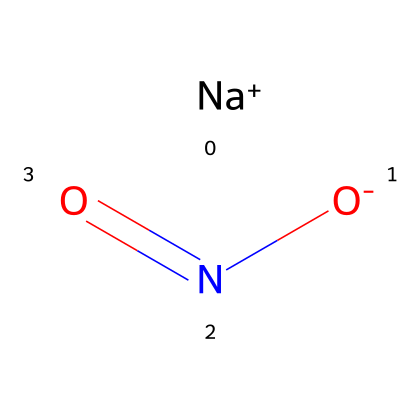What is the molecular formula of sodium nitrite? The SMILES representation indicates the presence of a sodium ion (Na+) and a nitrite ion (NO2-). Adding these together, the molecular formula can be derived as NaNO2.
Answer: NaNO2 How many atoms are present in sodium nitrite? The molecular formula NaNO2 contains three different elements: one sodium atom, one nitrogen atom, and two oxygen atoms. Thus, the total number of atoms is four.
Answer: 4 What is the charge of the sodium ion in this compound? The SMILES representation shows [Na+], indicating that sodium has a positive charge.
Answer: positive What is the oxidation state of nitrogen in sodium nitrite? In NaNO2, the oxidation state of nitrogen is +3. This can be derived from the overall charge balance of the compound (considering each oxygen atom's typical oxidation state of -2).
Answer: +3 How does sodium nitrite contribute to food preservation? Sodium nitrite inhibits bacterial growth and prevents spoilage by interfering with the bacterial enzyme systems, especially in processed meats.
Answer: inhibits bacterial growth What specific impact does sodium nitrite have on health and crime-related behaviors? Sodium nitrite can form nitrosamines when cooked at high temperatures, which are carcinogenic. This health risk may influence socioeconomic factors related to crime, like healthcare access and community safety.
Answer: carcinogenic What is the significance of sodium nitrite in processed meats from a food safety perspective? Sodium nitrite is crucial as it prevents botulism, a severe foodborne illness, thereby ensuring safer consumption of processed meats.
Answer: prevents botulism 